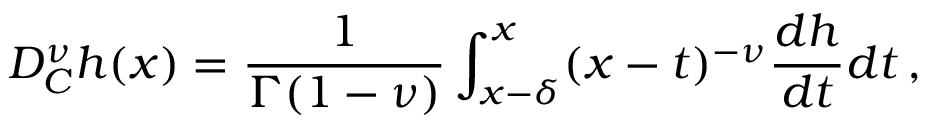<formula> <loc_0><loc_0><loc_500><loc_500>D _ { C } ^ { \nu } h ( x ) = \frac { 1 } { \Gamma ( 1 - \nu ) } \int _ { x - \delta } ^ { x } ( x - t ) ^ { - \nu } \frac { d h } { d t } d t \, ,</formula> 